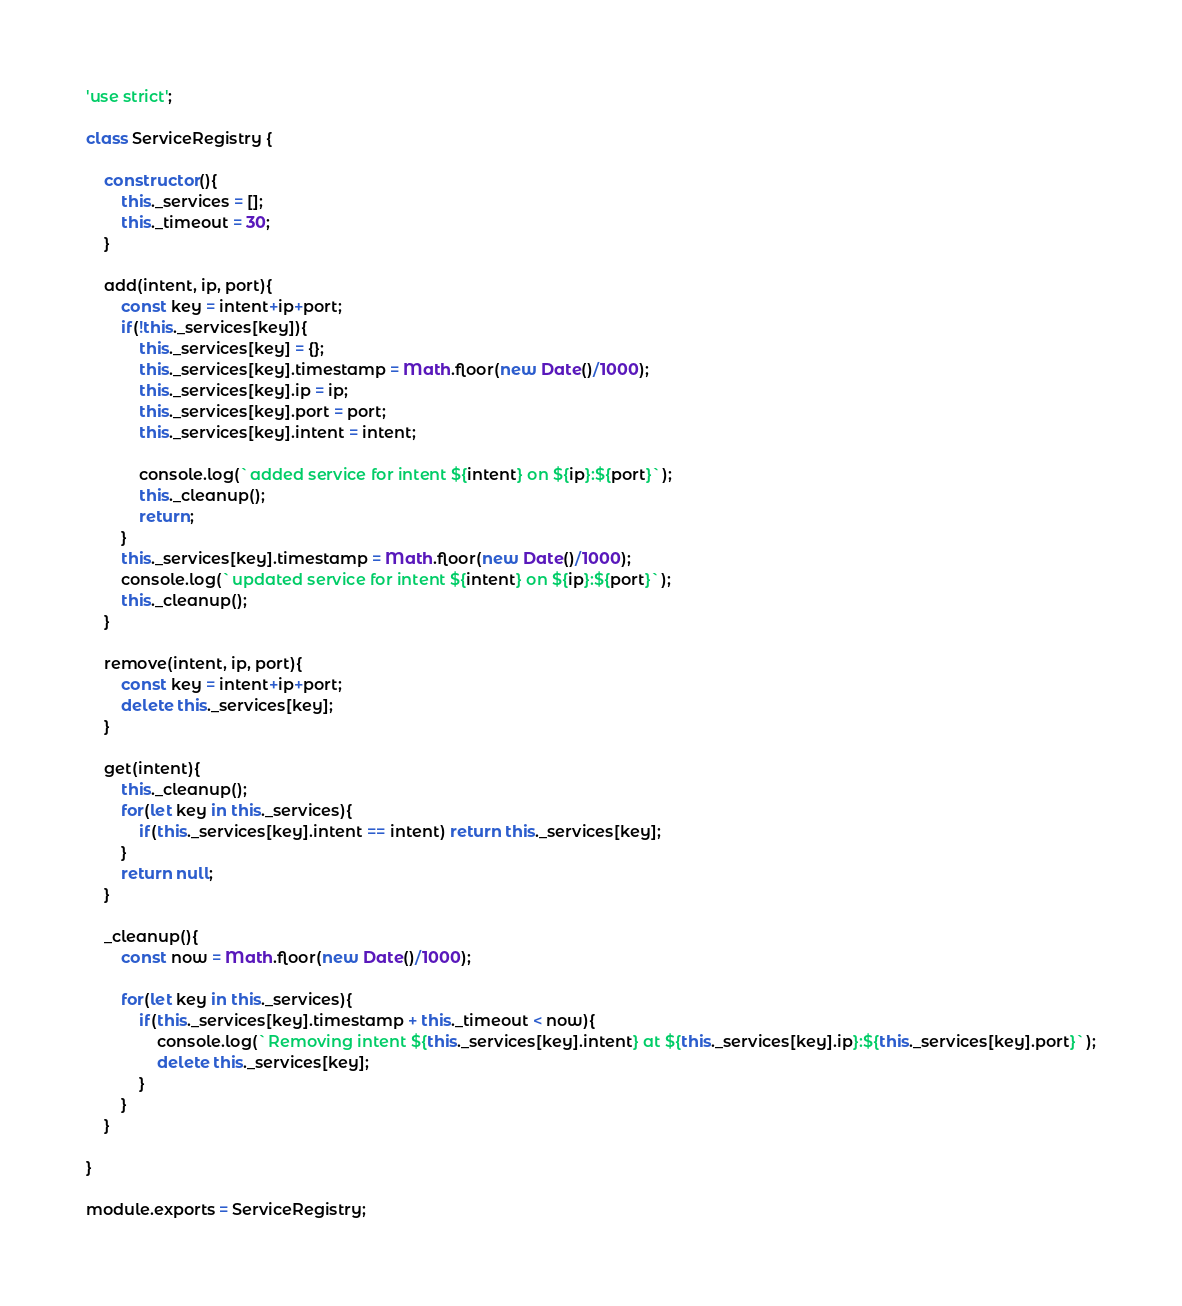<code> <loc_0><loc_0><loc_500><loc_500><_JavaScript_>'use strict';

class ServiceRegistry {

	constructor(){
		this._services = [];
		this._timeout = 30;
	}

	add(intent, ip, port){
		const key = intent+ip+port;
		if(!this._services[key]){
			this._services[key] = {};
			this._services[key].timestamp = Math.floor(new Date()/1000);
			this._services[key].ip = ip;
			this._services[key].port = port;
			this._services[key].intent = intent;

			console.log(`added service for intent ${intent} on ${ip}:${port}`);
			this._cleanup();
			return;
		}
		this._services[key].timestamp = Math.floor(new Date()/1000);
		console.log(`updated service for intent ${intent} on ${ip}:${port}`);
		this._cleanup();
	}

	remove(intent, ip, port){
		const key = intent+ip+port;
		delete this._services[key];
	}

	get(intent){
		this._cleanup();
		for(let key in this._services){
			if(this._services[key].intent == intent) return this._services[key];
		}
		return null;
	}

	_cleanup(){
		const now = Math.floor(new Date()/1000);

		for(let key in this._services){
			if(this._services[key].timestamp + this._timeout < now){
				console.log(`Removing intent ${this._services[key].intent} at ${this._services[key].ip}:${this._services[key].port}`);
				delete this._services[key];
			}
		}
	}

}

module.exports = ServiceRegistry;</code> 